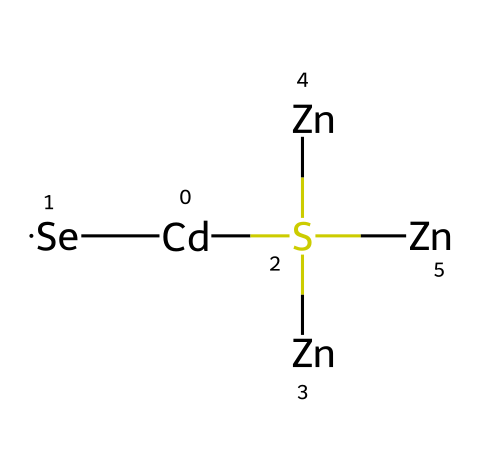What elements are present in this quantum dot structure? The SMILES representation includes Cadmium (Cd), Selenium (Se), Sulfur (S), and Zinc (Zn). Each element is represented explicitly in the SMILES string.
Answer: Cadmium, Selenium, Sulfur, Zinc How many Zinc atoms are in this quantum dot structure? By analyzing the SMILES, we see three instances of Zinc (Zn) present, as indicated by the repeated occurrence in the structure.
Answer: three What type of bonding is most likely present in this quantum dot? Quantum dots typically exhibit covalent bonding due to the sharing of electrons, especially between the transition metals and the chalcogens in the structure.
Answer: covalent What is the central atom in this quantum dot structure? The central atom can be identified as Cadmium (Cd), which serves as a key element in the construction of quantum dots in this particular structure.
Answer: Cadmium How does the presence of Selenium affect the properties of this quantum dot? Selenium incorporation in quantum dots typically impacts the bandgap and optical properties, enabling tunability of the material's electronic behavior.
Answer: bandgap What role does the Sulfur atom play in this quantum dot? Sulfur typically provides stability to the quantum dot's structure and can influence the optical properties and electron distribution by interacting with other atoms.
Answer: stability 